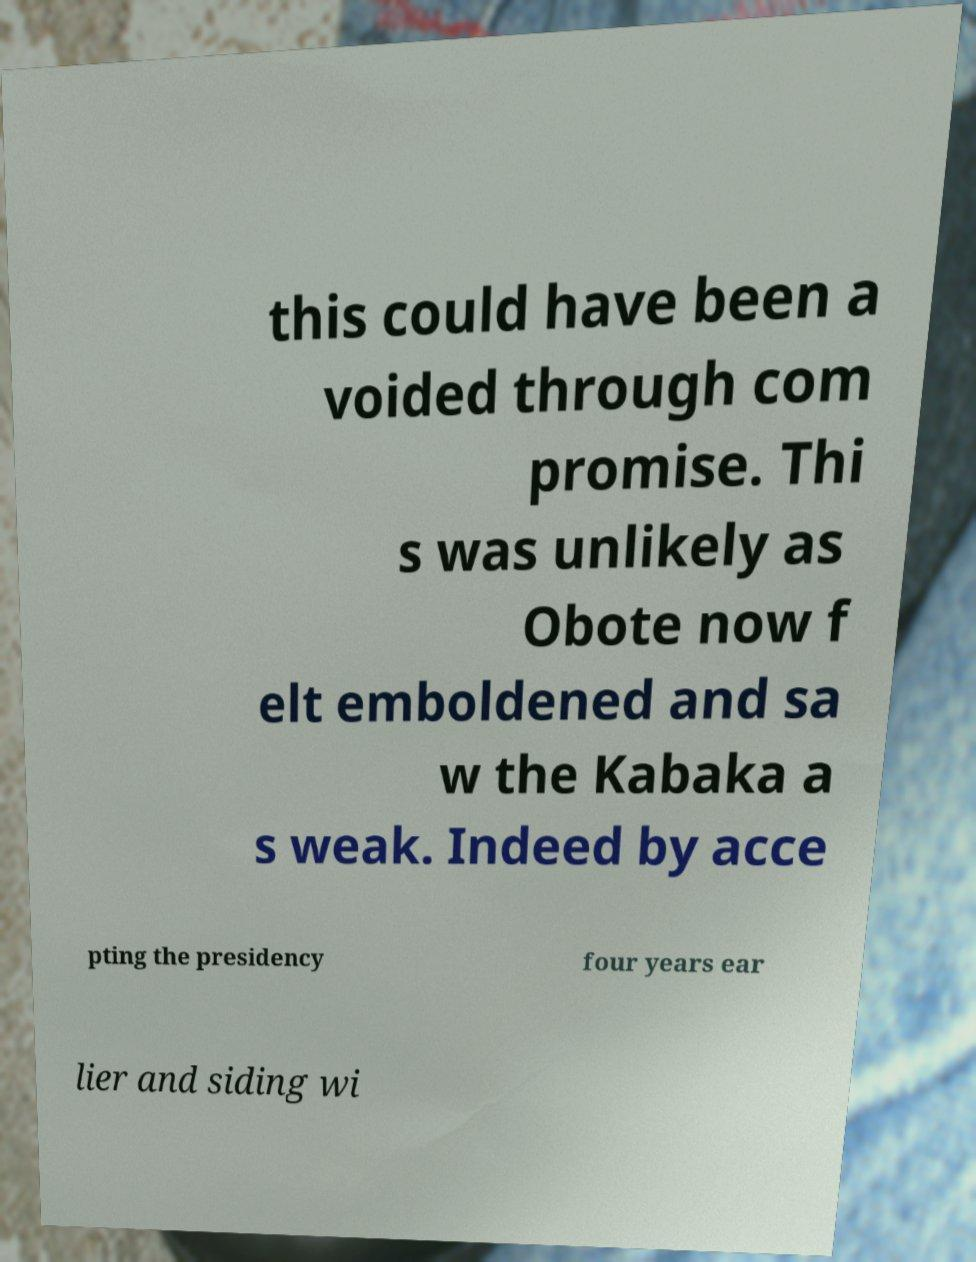For documentation purposes, I need the text within this image transcribed. Could you provide that? this could have been a voided through com promise. Thi s was unlikely as Obote now f elt emboldened and sa w the Kabaka a s weak. Indeed by acce pting the presidency four years ear lier and siding wi 